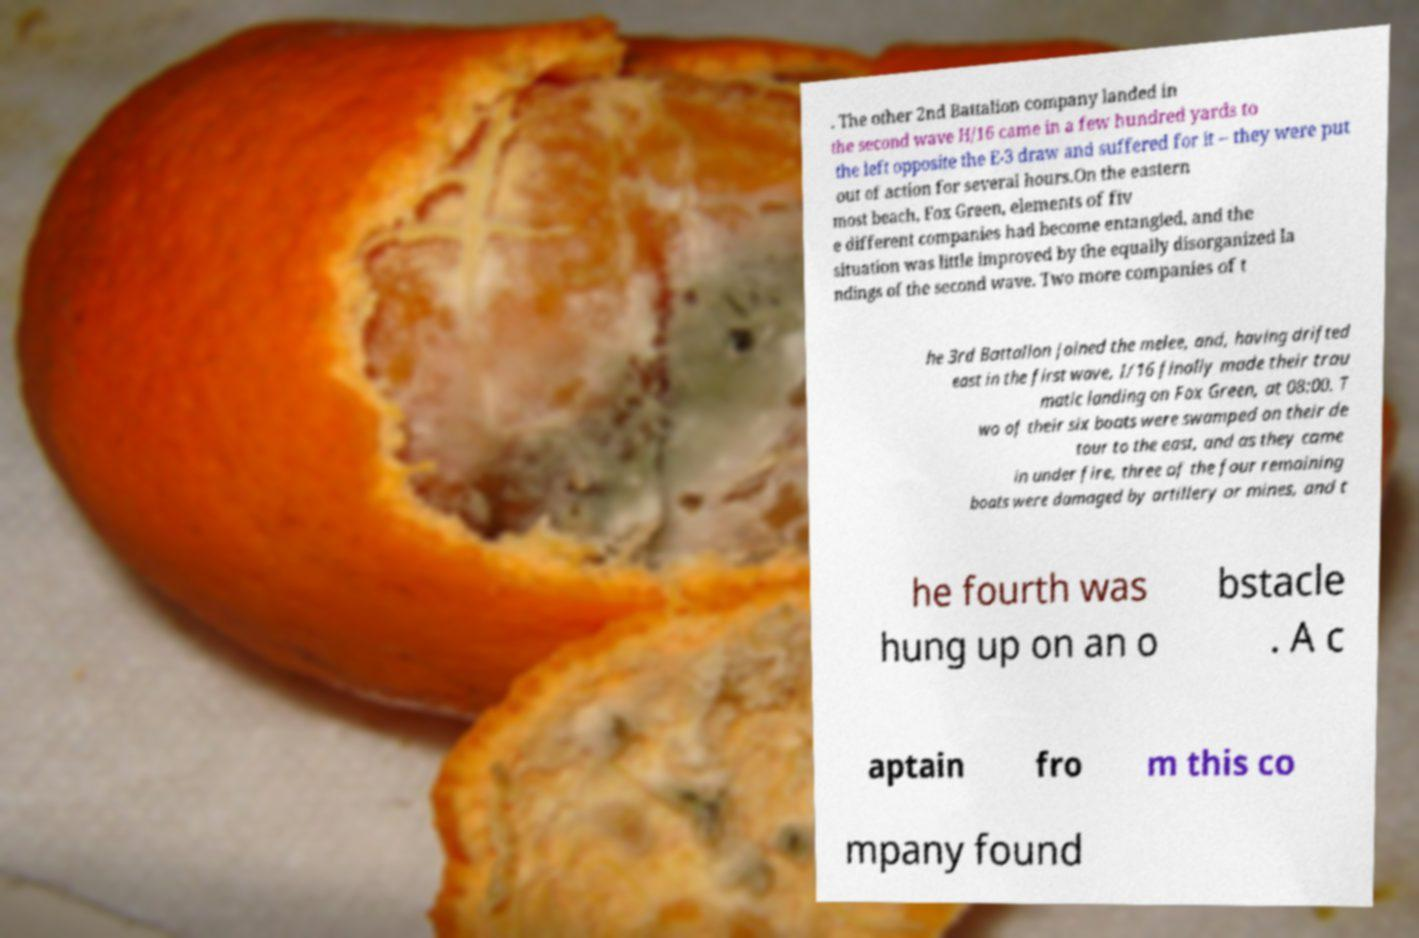Please read and relay the text visible in this image. What does it say? . The other 2nd Battalion company landed in the second wave H/16 came in a few hundred yards to the left opposite the E-3 draw and suffered for it – they were put out of action for several hours.On the eastern most beach, Fox Green, elements of fiv e different companies had become entangled, and the situation was little improved by the equally disorganized la ndings of the second wave. Two more companies of t he 3rd Battalion joined the melee, and, having drifted east in the first wave, I/16 finally made their trau matic landing on Fox Green, at 08:00. T wo of their six boats were swamped on their de tour to the east, and as they came in under fire, three of the four remaining boats were damaged by artillery or mines, and t he fourth was hung up on an o bstacle . A c aptain fro m this co mpany found 